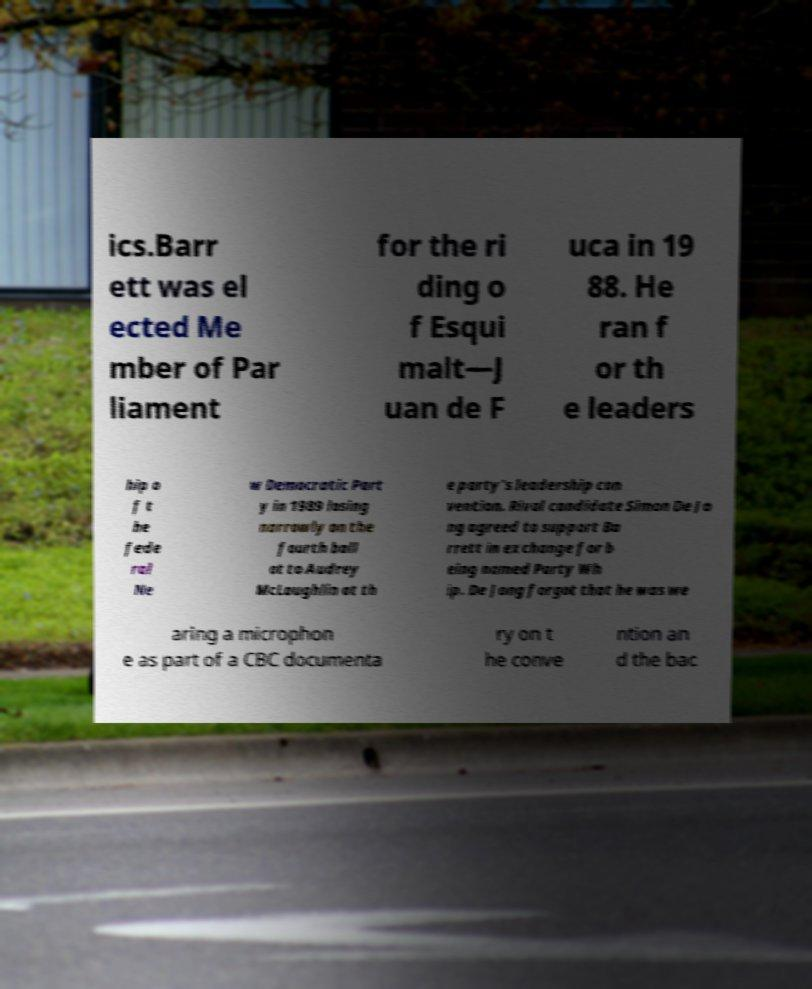I need the written content from this picture converted into text. Can you do that? ics.Barr ett was el ected Me mber of Par liament for the ri ding o f Esqui malt—J uan de F uca in 19 88. He ran f or th e leaders hip o f t he fede ral Ne w Democratic Part y in 1989 losing narrowly on the fourth ball ot to Audrey McLaughlin at th e party's leadership con vention. Rival candidate Simon De Jo ng agreed to support Ba rrett in exchange for b eing named Party Wh ip. De Jong forgot that he was we aring a microphon e as part of a CBC documenta ry on t he conve ntion an d the bac 